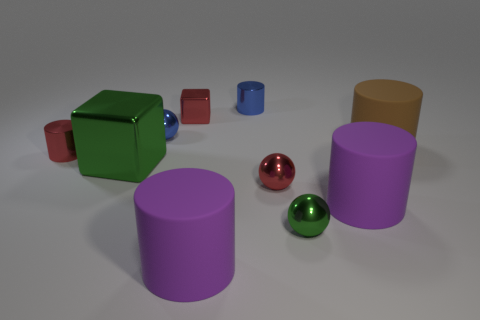Is the size of the red metal object that is on the left side of the green shiny block the same as the purple thing on the right side of the tiny red metal ball?
Provide a succinct answer. No. What size is the red object that is the same shape as the brown thing?
Ensure brevity in your answer.  Small. There is a red metal sphere; is it the same size as the purple rubber object to the right of the tiny green object?
Offer a very short reply. No. Is there a block that is in front of the purple rubber cylinder behind the green sphere?
Offer a very short reply. No. What is the shape of the red metallic thing that is in front of the large green thing?
Provide a short and direct response. Sphere. There is a tiny thing that is the same color as the big block; what material is it?
Provide a succinct answer. Metal. The metal sphere left of the cube that is to the right of the big cube is what color?
Offer a very short reply. Blue. Does the green metallic ball have the same size as the red block?
Offer a very short reply. Yes. What material is the tiny red object that is the same shape as the large brown thing?
Ensure brevity in your answer.  Metal. What number of red spheres have the same size as the blue cylinder?
Provide a succinct answer. 1. 